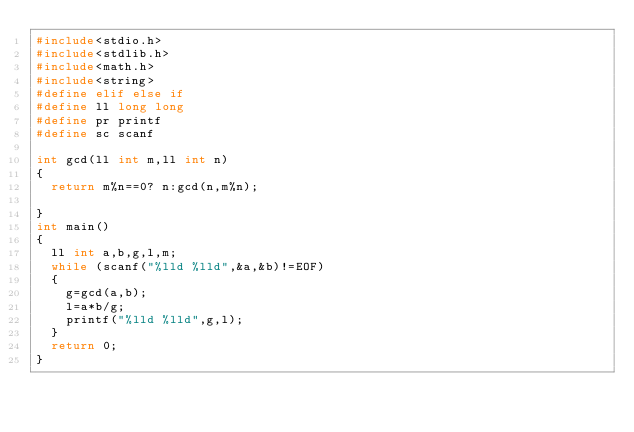<code> <loc_0><loc_0><loc_500><loc_500><_C_>#include<stdio.h>
#include<stdlib.h>
#include<math.h>
#include<string>
#define elif else if
#define ll long long
#define pr printf
#define sc scanf

int gcd(ll int m,ll int n)
{
	return m%n==0? n:gcd(n,m%n);
	
}
int main()
{
	ll int a,b,g,l,m;
	while (scanf("%lld %lld",&a,&b)!=EOF)
	{
		g=gcd(a,b);
		l=a*b/g;
		printf("%lld %lld",g,l);
	}
	return 0; 
} </code> 